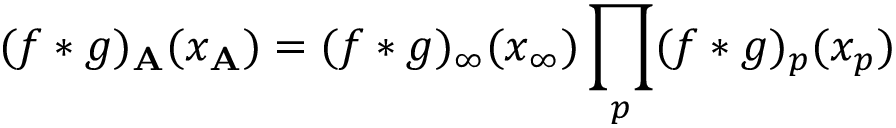Convert formula to latex. <formula><loc_0><loc_0><loc_500><loc_500>( f \ast g ) _ { A } ( x _ { A } ) = ( f \ast g ) _ { \infty } ( x _ { \infty } ) \prod _ { p } ( f \ast g ) _ { p } ( x _ { p } )</formula> 